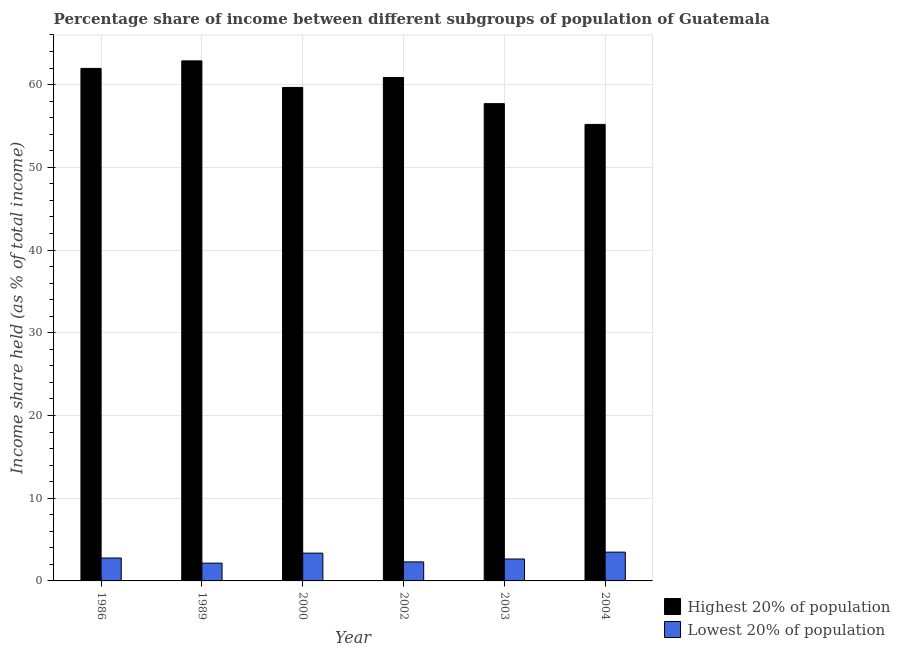How many bars are there on the 3rd tick from the right?
Keep it short and to the point. 2. What is the label of the 1st group of bars from the left?
Provide a succinct answer. 1986. In how many cases, is the number of bars for a given year not equal to the number of legend labels?
Give a very brief answer. 0. What is the income share held by highest 20% of the population in 2004?
Give a very brief answer. 55.19. Across all years, what is the maximum income share held by highest 20% of the population?
Give a very brief answer. 62.87. Across all years, what is the minimum income share held by lowest 20% of the population?
Keep it short and to the point. 2.15. In which year was the income share held by lowest 20% of the population minimum?
Offer a very short reply. 1989. What is the total income share held by lowest 20% of the population in the graph?
Keep it short and to the point. 16.71. What is the difference between the income share held by lowest 20% of the population in 2003 and that in 2004?
Ensure brevity in your answer.  -0.83. What is the difference between the income share held by lowest 20% of the population in 1989 and the income share held by highest 20% of the population in 1986?
Make the answer very short. -0.62. What is the average income share held by lowest 20% of the population per year?
Offer a terse response. 2.78. What is the ratio of the income share held by lowest 20% of the population in 1986 to that in 2002?
Your answer should be very brief. 1.2. Is the income share held by highest 20% of the population in 1986 less than that in 2000?
Provide a short and direct response. No. What is the difference between the highest and the second highest income share held by lowest 20% of the population?
Keep it short and to the point. 0.12. What is the difference between the highest and the lowest income share held by lowest 20% of the population?
Provide a short and direct response. 1.33. In how many years, is the income share held by lowest 20% of the population greater than the average income share held by lowest 20% of the population taken over all years?
Keep it short and to the point. 2. Is the sum of the income share held by highest 20% of the population in 1989 and 2002 greater than the maximum income share held by lowest 20% of the population across all years?
Make the answer very short. Yes. What does the 1st bar from the left in 2004 represents?
Give a very brief answer. Highest 20% of population. What does the 2nd bar from the right in 2004 represents?
Your response must be concise. Highest 20% of population. How many bars are there?
Give a very brief answer. 12. Are the values on the major ticks of Y-axis written in scientific E-notation?
Provide a short and direct response. No. Does the graph contain any zero values?
Ensure brevity in your answer.  No. Does the graph contain grids?
Offer a terse response. Yes. How many legend labels are there?
Your response must be concise. 2. How are the legend labels stacked?
Give a very brief answer. Vertical. What is the title of the graph?
Give a very brief answer. Percentage share of income between different subgroups of population of Guatemala. What is the label or title of the Y-axis?
Offer a very short reply. Income share held (as % of total income). What is the Income share held (as % of total income) of Highest 20% of population in 1986?
Offer a very short reply. 61.96. What is the Income share held (as % of total income) in Lowest 20% of population in 1986?
Provide a short and direct response. 2.77. What is the Income share held (as % of total income) of Highest 20% of population in 1989?
Ensure brevity in your answer.  62.87. What is the Income share held (as % of total income) in Lowest 20% of population in 1989?
Make the answer very short. 2.15. What is the Income share held (as % of total income) of Highest 20% of population in 2000?
Provide a short and direct response. 59.66. What is the Income share held (as % of total income) of Lowest 20% of population in 2000?
Offer a very short reply. 3.36. What is the Income share held (as % of total income) of Highest 20% of population in 2002?
Ensure brevity in your answer.  60.86. What is the Income share held (as % of total income) of Highest 20% of population in 2003?
Ensure brevity in your answer.  57.7. What is the Income share held (as % of total income) in Lowest 20% of population in 2003?
Make the answer very short. 2.65. What is the Income share held (as % of total income) of Highest 20% of population in 2004?
Make the answer very short. 55.19. What is the Income share held (as % of total income) in Lowest 20% of population in 2004?
Make the answer very short. 3.48. Across all years, what is the maximum Income share held (as % of total income) of Highest 20% of population?
Your answer should be compact. 62.87. Across all years, what is the maximum Income share held (as % of total income) in Lowest 20% of population?
Offer a terse response. 3.48. Across all years, what is the minimum Income share held (as % of total income) of Highest 20% of population?
Your response must be concise. 55.19. Across all years, what is the minimum Income share held (as % of total income) in Lowest 20% of population?
Ensure brevity in your answer.  2.15. What is the total Income share held (as % of total income) in Highest 20% of population in the graph?
Make the answer very short. 358.24. What is the total Income share held (as % of total income) of Lowest 20% of population in the graph?
Offer a terse response. 16.71. What is the difference between the Income share held (as % of total income) in Highest 20% of population in 1986 and that in 1989?
Make the answer very short. -0.91. What is the difference between the Income share held (as % of total income) in Lowest 20% of population in 1986 and that in 1989?
Keep it short and to the point. 0.62. What is the difference between the Income share held (as % of total income) of Lowest 20% of population in 1986 and that in 2000?
Your answer should be very brief. -0.59. What is the difference between the Income share held (as % of total income) in Lowest 20% of population in 1986 and that in 2002?
Your answer should be compact. 0.47. What is the difference between the Income share held (as % of total income) in Highest 20% of population in 1986 and that in 2003?
Your response must be concise. 4.26. What is the difference between the Income share held (as % of total income) in Lowest 20% of population in 1986 and that in 2003?
Offer a terse response. 0.12. What is the difference between the Income share held (as % of total income) in Highest 20% of population in 1986 and that in 2004?
Your answer should be very brief. 6.77. What is the difference between the Income share held (as % of total income) of Lowest 20% of population in 1986 and that in 2004?
Offer a very short reply. -0.71. What is the difference between the Income share held (as % of total income) of Highest 20% of population in 1989 and that in 2000?
Your answer should be compact. 3.21. What is the difference between the Income share held (as % of total income) in Lowest 20% of population in 1989 and that in 2000?
Offer a terse response. -1.21. What is the difference between the Income share held (as % of total income) of Highest 20% of population in 1989 and that in 2002?
Ensure brevity in your answer.  2.01. What is the difference between the Income share held (as % of total income) of Lowest 20% of population in 1989 and that in 2002?
Give a very brief answer. -0.15. What is the difference between the Income share held (as % of total income) of Highest 20% of population in 1989 and that in 2003?
Your answer should be compact. 5.17. What is the difference between the Income share held (as % of total income) in Lowest 20% of population in 1989 and that in 2003?
Your answer should be compact. -0.5. What is the difference between the Income share held (as % of total income) of Highest 20% of population in 1989 and that in 2004?
Give a very brief answer. 7.68. What is the difference between the Income share held (as % of total income) of Lowest 20% of population in 1989 and that in 2004?
Ensure brevity in your answer.  -1.33. What is the difference between the Income share held (as % of total income) of Highest 20% of population in 2000 and that in 2002?
Provide a succinct answer. -1.2. What is the difference between the Income share held (as % of total income) in Lowest 20% of population in 2000 and that in 2002?
Offer a terse response. 1.06. What is the difference between the Income share held (as % of total income) of Highest 20% of population in 2000 and that in 2003?
Offer a very short reply. 1.96. What is the difference between the Income share held (as % of total income) in Lowest 20% of population in 2000 and that in 2003?
Make the answer very short. 0.71. What is the difference between the Income share held (as % of total income) in Highest 20% of population in 2000 and that in 2004?
Offer a very short reply. 4.47. What is the difference between the Income share held (as % of total income) in Lowest 20% of population in 2000 and that in 2004?
Make the answer very short. -0.12. What is the difference between the Income share held (as % of total income) of Highest 20% of population in 2002 and that in 2003?
Make the answer very short. 3.16. What is the difference between the Income share held (as % of total income) in Lowest 20% of population in 2002 and that in 2003?
Offer a very short reply. -0.35. What is the difference between the Income share held (as % of total income) of Highest 20% of population in 2002 and that in 2004?
Ensure brevity in your answer.  5.67. What is the difference between the Income share held (as % of total income) of Lowest 20% of population in 2002 and that in 2004?
Offer a terse response. -1.18. What is the difference between the Income share held (as % of total income) in Highest 20% of population in 2003 and that in 2004?
Offer a terse response. 2.51. What is the difference between the Income share held (as % of total income) of Lowest 20% of population in 2003 and that in 2004?
Give a very brief answer. -0.83. What is the difference between the Income share held (as % of total income) of Highest 20% of population in 1986 and the Income share held (as % of total income) of Lowest 20% of population in 1989?
Give a very brief answer. 59.81. What is the difference between the Income share held (as % of total income) of Highest 20% of population in 1986 and the Income share held (as % of total income) of Lowest 20% of population in 2000?
Your answer should be compact. 58.6. What is the difference between the Income share held (as % of total income) of Highest 20% of population in 1986 and the Income share held (as % of total income) of Lowest 20% of population in 2002?
Your answer should be compact. 59.66. What is the difference between the Income share held (as % of total income) in Highest 20% of population in 1986 and the Income share held (as % of total income) in Lowest 20% of population in 2003?
Your answer should be very brief. 59.31. What is the difference between the Income share held (as % of total income) of Highest 20% of population in 1986 and the Income share held (as % of total income) of Lowest 20% of population in 2004?
Offer a very short reply. 58.48. What is the difference between the Income share held (as % of total income) in Highest 20% of population in 1989 and the Income share held (as % of total income) in Lowest 20% of population in 2000?
Give a very brief answer. 59.51. What is the difference between the Income share held (as % of total income) of Highest 20% of population in 1989 and the Income share held (as % of total income) of Lowest 20% of population in 2002?
Your answer should be compact. 60.57. What is the difference between the Income share held (as % of total income) of Highest 20% of population in 1989 and the Income share held (as % of total income) of Lowest 20% of population in 2003?
Give a very brief answer. 60.22. What is the difference between the Income share held (as % of total income) of Highest 20% of population in 1989 and the Income share held (as % of total income) of Lowest 20% of population in 2004?
Your answer should be very brief. 59.39. What is the difference between the Income share held (as % of total income) in Highest 20% of population in 2000 and the Income share held (as % of total income) in Lowest 20% of population in 2002?
Ensure brevity in your answer.  57.36. What is the difference between the Income share held (as % of total income) in Highest 20% of population in 2000 and the Income share held (as % of total income) in Lowest 20% of population in 2003?
Keep it short and to the point. 57.01. What is the difference between the Income share held (as % of total income) in Highest 20% of population in 2000 and the Income share held (as % of total income) in Lowest 20% of population in 2004?
Your response must be concise. 56.18. What is the difference between the Income share held (as % of total income) in Highest 20% of population in 2002 and the Income share held (as % of total income) in Lowest 20% of population in 2003?
Give a very brief answer. 58.21. What is the difference between the Income share held (as % of total income) of Highest 20% of population in 2002 and the Income share held (as % of total income) of Lowest 20% of population in 2004?
Your answer should be compact. 57.38. What is the difference between the Income share held (as % of total income) of Highest 20% of population in 2003 and the Income share held (as % of total income) of Lowest 20% of population in 2004?
Provide a short and direct response. 54.22. What is the average Income share held (as % of total income) in Highest 20% of population per year?
Offer a very short reply. 59.71. What is the average Income share held (as % of total income) in Lowest 20% of population per year?
Your answer should be compact. 2.79. In the year 1986, what is the difference between the Income share held (as % of total income) of Highest 20% of population and Income share held (as % of total income) of Lowest 20% of population?
Your answer should be compact. 59.19. In the year 1989, what is the difference between the Income share held (as % of total income) of Highest 20% of population and Income share held (as % of total income) of Lowest 20% of population?
Provide a succinct answer. 60.72. In the year 2000, what is the difference between the Income share held (as % of total income) of Highest 20% of population and Income share held (as % of total income) of Lowest 20% of population?
Give a very brief answer. 56.3. In the year 2002, what is the difference between the Income share held (as % of total income) of Highest 20% of population and Income share held (as % of total income) of Lowest 20% of population?
Offer a very short reply. 58.56. In the year 2003, what is the difference between the Income share held (as % of total income) in Highest 20% of population and Income share held (as % of total income) in Lowest 20% of population?
Provide a succinct answer. 55.05. In the year 2004, what is the difference between the Income share held (as % of total income) in Highest 20% of population and Income share held (as % of total income) in Lowest 20% of population?
Offer a terse response. 51.71. What is the ratio of the Income share held (as % of total income) in Highest 20% of population in 1986 to that in 1989?
Keep it short and to the point. 0.99. What is the ratio of the Income share held (as % of total income) in Lowest 20% of population in 1986 to that in 1989?
Offer a terse response. 1.29. What is the ratio of the Income share held (as % of total income) in Highest 20% of population in 1986 to that in 2000?
Your answer should be very brief. 1.04. What is the ratio of the Income share held (as % of total income) of Lowest 20% of population in 1986 to that in 2000?
Provide a short and direct response. 0.82. What is the ratio of the Income share held (as % of total income) of Highest 20% of population in 1986 to that in 2002?
Provide a succinct answer. 1.02. What is the ratio of the Income share held (as % of total income) of Lowest 20% of population in 1986 to that in 2002?
Offer a very short reply. 1.2. What is the ratio of the Income share held (as % of total income) in Highest 20% of population in 1986 to that in 2003?
Make the answer very short. 1.07. What is the ratio of the Income share held (as % of total income) in Lowest 20% of population in 1986 to that in 2003?
Make the answer very short. 1.05. What is the ratio of the Income share held (as % of total income) in Highest 20% of population in 1986 to that in 2004?
Provide a succinct answer. 1.12. What is the ratio of the Income share held (as % of total income) of Lowest 20% of population in 1986 to that in 2004?
Keep it short and to the point. 0.8. What is the ratio of the Income share held (as % of total income) of Highest 20% of population in 1989 to that in 2000?
Offer a terse response. 1.05. What is the ratio of the Income share held (as % of total income) in Lowest 20% of population in 1989 to that in 2000?
Offer a terse response. 0.64. What is the ratio of the Income share held (as % of total income) in Highest 20% of population in 1989 to that in 2002?
Your answer should be compact. 1.03. What is the ratio of the Income share held (as % of total income) of Lowest 20% of population in 1989 to that in 2002?
Offer a terse response. 0.93. What is the ratio of the Income share held (as % of total income) in Highest 20% of population in 1989 to that in 2003?
Your response must be concise. 1.09. What is the ratio of the Income share held (as % of total income) of Lowest 20% of population in 1989 to that in 2003?
Make the answer very short. 0.81. What is the ratio of the Income share held (as % of total income) in Highest 20% of population in 1989 to that in 2004?
Your response must be concise. 1.14. What is the ratio of the Income share held (as % of total income) of Lowest 20% of population in 1989 to that in 2004?
Keep it short and to the point. 0.62. What is the ratio of the Income share held (as % of total income) in Highest 20% of population in 2000 to that in 2002?
Your response must be concise. 0.98. What is the ratio of the Income share held (as % of total income) of Lowest 20% of population in 2000 to that in 2002?
Keep it short and to the point. 1.46. What is the ratio of the Income share held (as % of total income) of Highest 20% of population in 2000 to that in 2003?
Make the answer very short. 1.03. What is the ratio of the Income share held (as % of total income) of Lowest 20% of population in 2000 to that in 2003?
Offer a very short reply. 1.27. What is the ratio of the Income share held (as % of total income) in Highest 20% of population in 2000 to that in 2004?
Make the answer very short. 1.08. What is the ratio of the Income share held (as % of total income) in Lowest 20% of population in 2000 to that in 2004?
Your answer should be compact. 0.97. What is the ratio of the Income share held (as % of total income) in Highest 20% of population in 2002 to that in 2003?
Provide a succinct answer. 1.05. What is the ratio of the Income share held (as % of total income) in Lowest 20% of population in 2002 to that in 2003?
Your answer should be compact. 0.87. What is the ratio of the Income share held (as % of total income) of Highest 20% of population in 2002 to that in 2004?
Your answer should be compact. 1.1. What is the ratio of the Income share held (as % of total income) in Lowest 20% of population in 2002 to that in 2004?
Ensure brevity in your answer.  0.66. What is the ratio of the Income share held (as % of total income) in Highest 20% of population in 2003 to that in 2004?
Your response must be concise. 1.05. What is the ratio of the Income share held (as % of total income) of Lowest 20% of population in 2003 to that in 2004?
Your answer should be very brief. 0.76. What is the difference between the highest and the second highest Income share held (as % of total income) of Highest 20% of population?
Your answer should be very brief. 0.91. What is the difference between the highest and the second highest Income share held (as % of total income) of Lowest 20% of population?
Offer a very short reply. 0.12. What is the difference between the highest and the lowest Income share held (as % of total income) in Highest 20% of population?
Make the answer very short. 7.68. What is the difference between the highest and the lowest Income share held (as % of total income) in Lowest 20% of population?
Ensure brevity in your answer.  1.33. 